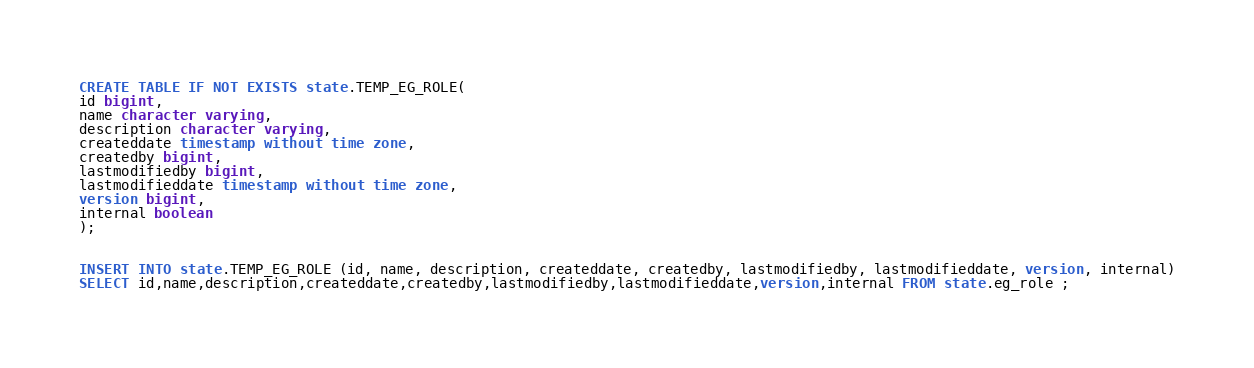Convert code to text. <code><loc_0><loc_0><loc_500><loc_500><_SQL_>CREATE TABLE IF NOT EXISTS state.TEMP_EG_ROLE(
id bigint,
name character varying,
description character varying,
createddate timestamp without time zone,
createdby bigint,
lastmodifiedby bigint,
lastmodifieddate timestamp without time zone,
version bigint,
internal boolean
);


INSERT INTO state.TEMP_EG_ROLE (id, name, description, createddate, createdby, lastmodifiedby, lastmodifieddate, version, internal)
SELECT id,name,description,createddate,createdby,lastmodifiedby,lastmodifieddate,version,internal FROM state.eg_role ;

</code> 